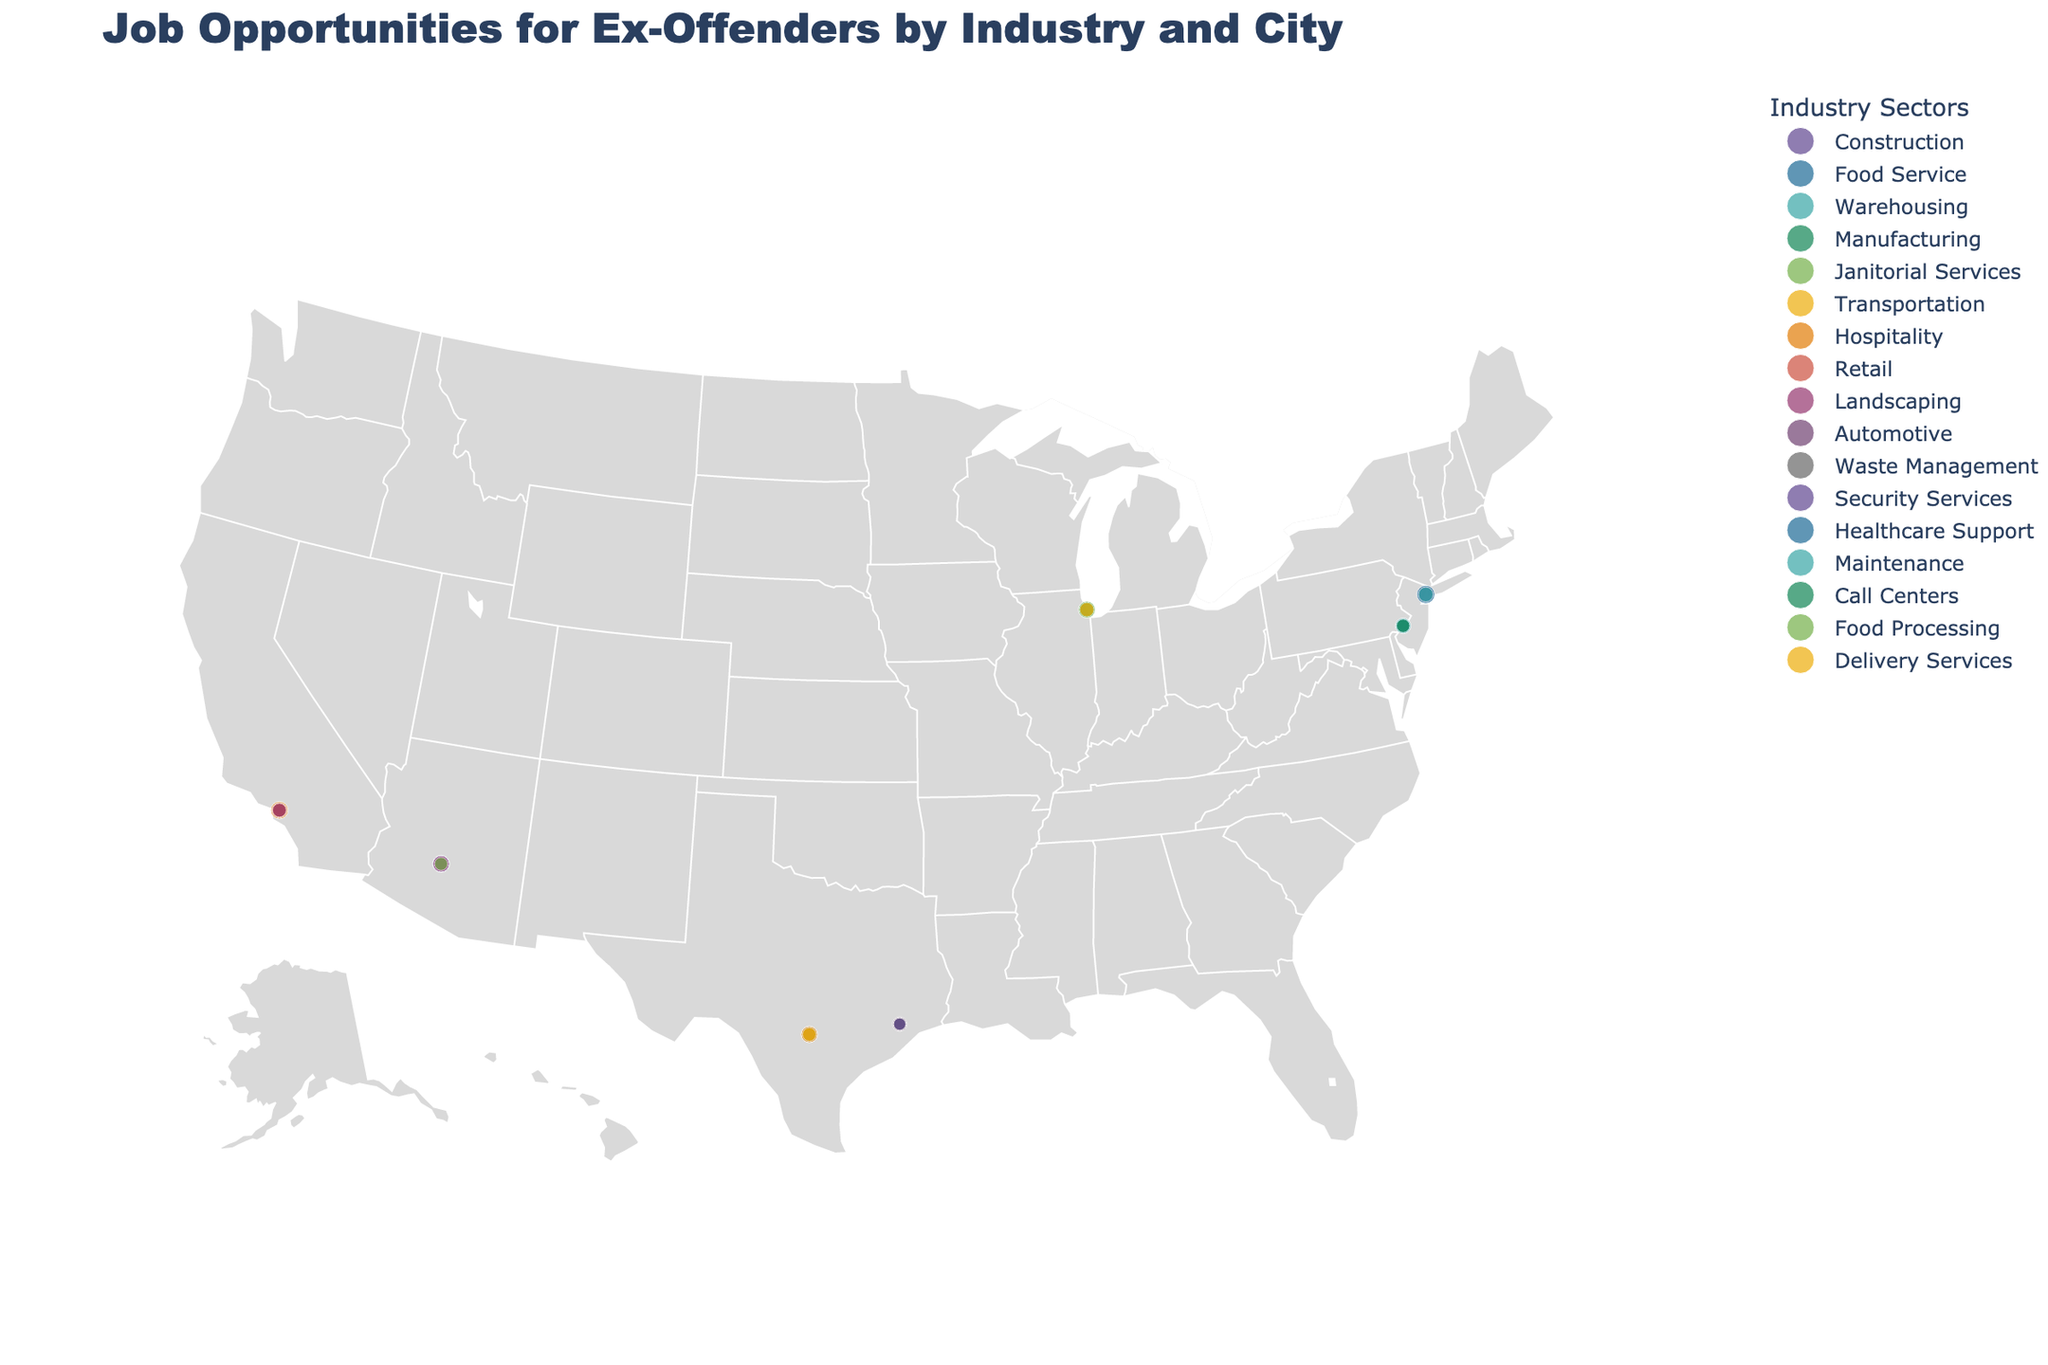What is the title of the plot? The title is prominently displayed at the top of the plot, indicating the subject matter being depicted.
Answer: Job Opportunities for Ex-Offenders by Industry and City Which city offers the highest percentage of job opportunities in the Hospitality industry? Look for the circle indicating the Hospitality industry and check each city's label for the percentage of opportunities in Hospitality.
Answer: Los Angeles Which industry has the largest size markers in San Antonio? By comparing the sizes of the markers in San Antonio, determine which industry's marker is the largest.
Answer: Hospitality Which city has the smallest percentage of job opportunities in the Waste Management industry? Identify the Waste Management industry marker and compare the percentage values for the cities.
Answer: Houston How many cities offer job opportunities in the Construction industry? Count the number of unique cities that have job opportunities listed under the Construction industry.
Answer: 2 Compare the percentage of opportunities in Maintenance between Philadelphia and other cities. Which city has the highest percentage? Locate the Maintenance industry markers, compare the percentages across all cities, and identify the highest one.
Answer: Philadelphia What is the sum of the percentages for the three industries listed in New York City? Add the percentages for Construction, Food Service, and Warehousing in New York City.
Answer: 46.4% Which city offers more job opportunities for ex-offenders in the Food Service industry, New York City or Phoenix? Look at the markers for the Food Service industry in both New York City and Phoenix, then compare the percentages.
Answer: New York City In which city does the Automotive industry offer job opportunities for ex-offenders? Identify the city associated with the Automotive industry marker on the plot.
Answer: Houston What is the difference in job opportunity percentages between the highest and lowest industries in Chicago? Determine the highest and lowest percentages for industries in Chicago and then find the difference between these values.
Answer: 16.3 - 11.9 = 4.4 